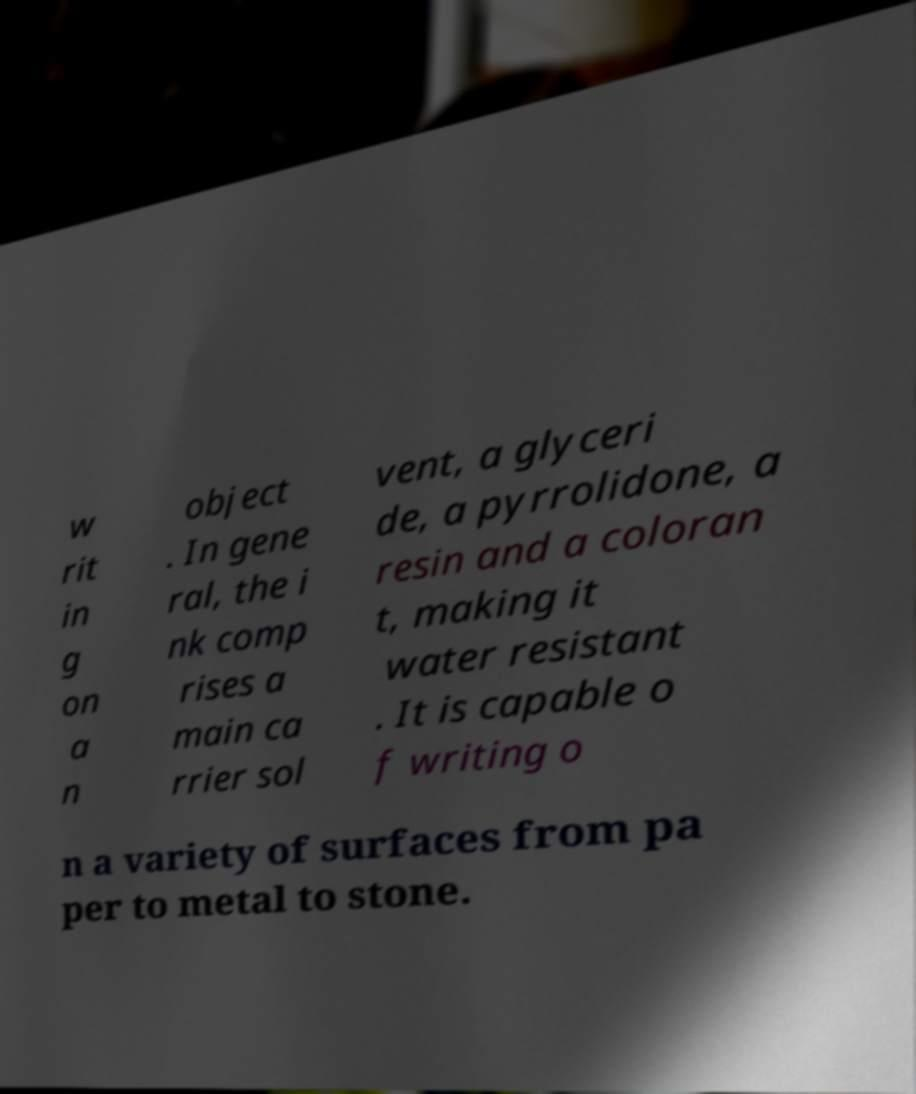Could you extract and type out the text from this image? w rit in g on a n object . In gene ral, the i nk comp rises a main ca rrier sol vent, a glyceri de, a pyrrolidone, a resin and a coloran t, making it water resistant . It is capable o f writing o n a variety of surfaces from pa per to metal to stone. 